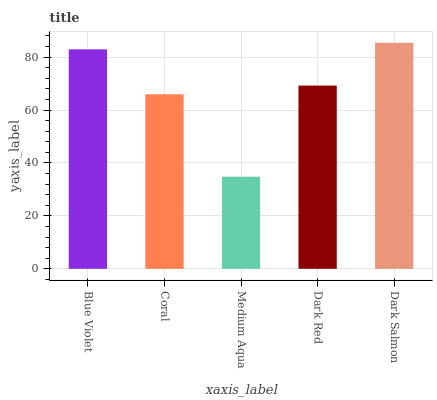Is Medium Aqua the minimum?
Answer yes or no. Yes. Is Dark Salmon the maximum?
Answer yes or no. Yes. Is Coral the minimum?
Answer yes or no. No. Is Coral the maximum?
Answer yes or no. No. Is Blue Violet greater than Coral?
Answer yes or no. Yes. Is Coral less than Blue Violet?
Answer yes or no. Yes. Is Coral greater than Blue Violet?
Answer yes or no. No. Is Blue Violet less than Coral?
Answer yes or no. No. Is Dark Red the high median?
Answer yes or no. Yes. Is Dark Red the low median?
Answer yes or no. Yes. Is Dark Salmon the high median?
Answer yes or no. No. Is Dark Salmon the low median?
Answer yes or no. No. 